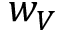<formula> <loc_0><loc_0><loc_500><loc_500>w _ { V }</formula> 